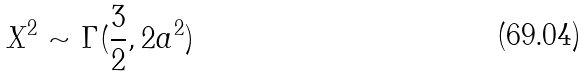Convert formula to latex. <formula><loc_0><loc_0><loc_500><loc_500>X ^ { 2 } \sim \Gamma ( \frac { 3 } { 2 } , 2 a ^ { 2 } )</formula> 